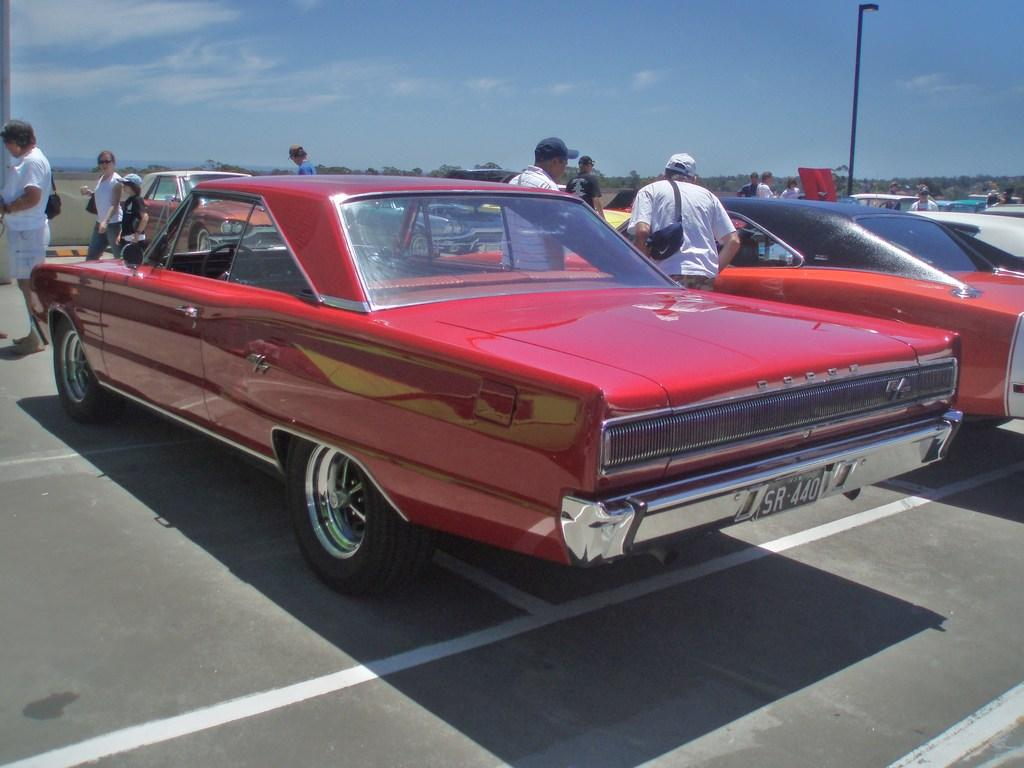What can be seen on the road in the image? There are cars on the road in the image. What are the people near the cars doing? There are people standing beside the cars. What object is visible in the image besides the cars and people? There is a pole visible in the image. What is the condition of the sky in the image? The sky appears to be cloudy in the image. Where are the friends hanging out in the image? There is no mention of friends in the image; it features cars, people, a pole, and a cloudy sky. What type of fang can be seen in the image? There are no fangs present in the image. 